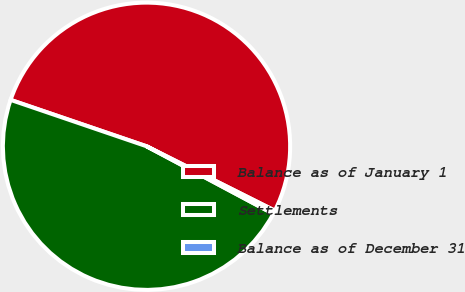Convert chart to OTSL. <chart><loc_0><loc_0><loc_500><loc_500><pie_chart><fcel>Balance as of January 1<fcel>Settlements<fcel>Balance as of December 31<nl><fcel>52.17%<fcel>47.44%<fcel>0.39%<nl></chart> 